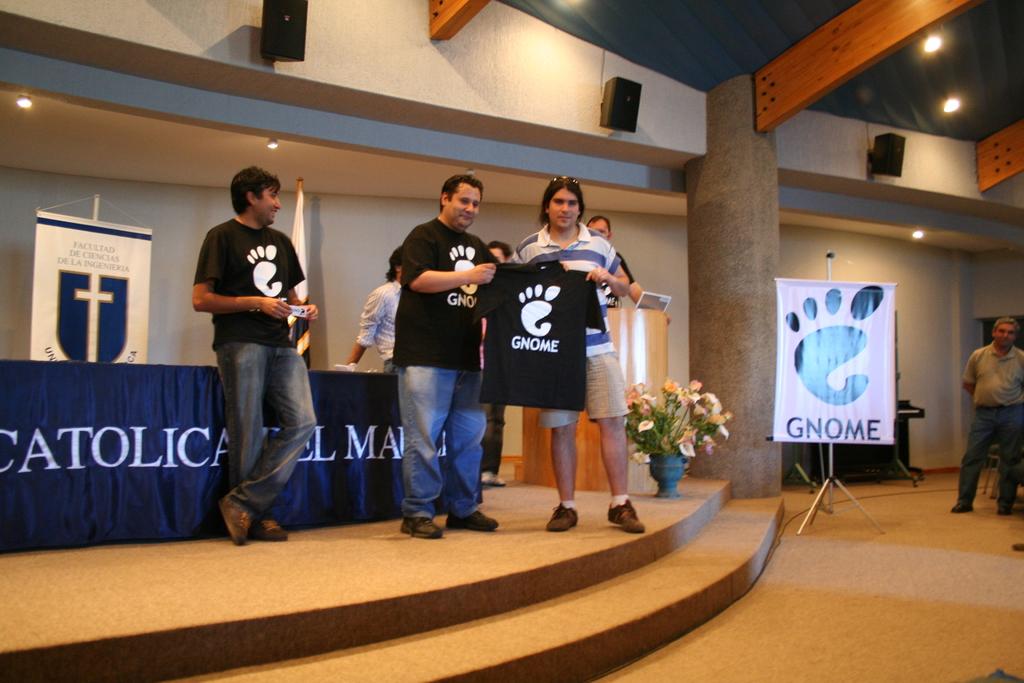What does it say under the foot logo?
Offer a very short reply. Gnome. What religion are they associated with?
Give a very brief answer. Catholic. 